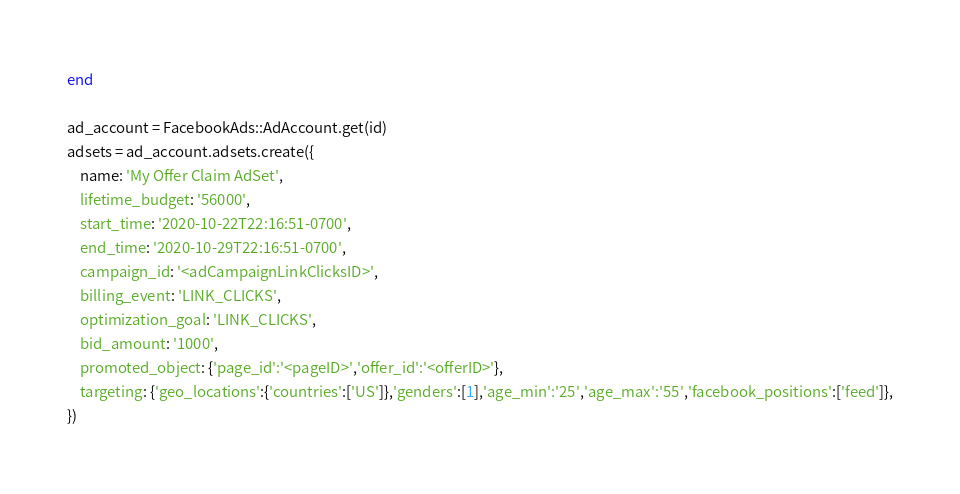Convert code to text. <code><loc_0><loc_0><loc_500><loc_500><_Ruby_>end

ad_account = FacebookAds::AdAccount.get(id)
adsets = ad_account.adsets.create({
    name: 'My Offer Claim AdSet',
    lifetime_budget: '56000',
    start_time: '2020-10-22T22:16:51-0700',
    end_time: '2020-10-29T22:16:51-0700',
    campaign_id: '<adCampaignLinkClicksID>',
    billing_event: 'LINK_CLICKS',
    optimization_goal: 'LINK_CLICKS',
    bid_amount: '1000',
    promoted_object: {'page_id':'<pageID>','offer_id':'<offerID>'},
    targeting: {'geo_locations':{'countries':['US']},'genders':[1],'age_min':'25','age_max':'55','facebook_positions':['feed']},
})</code> 